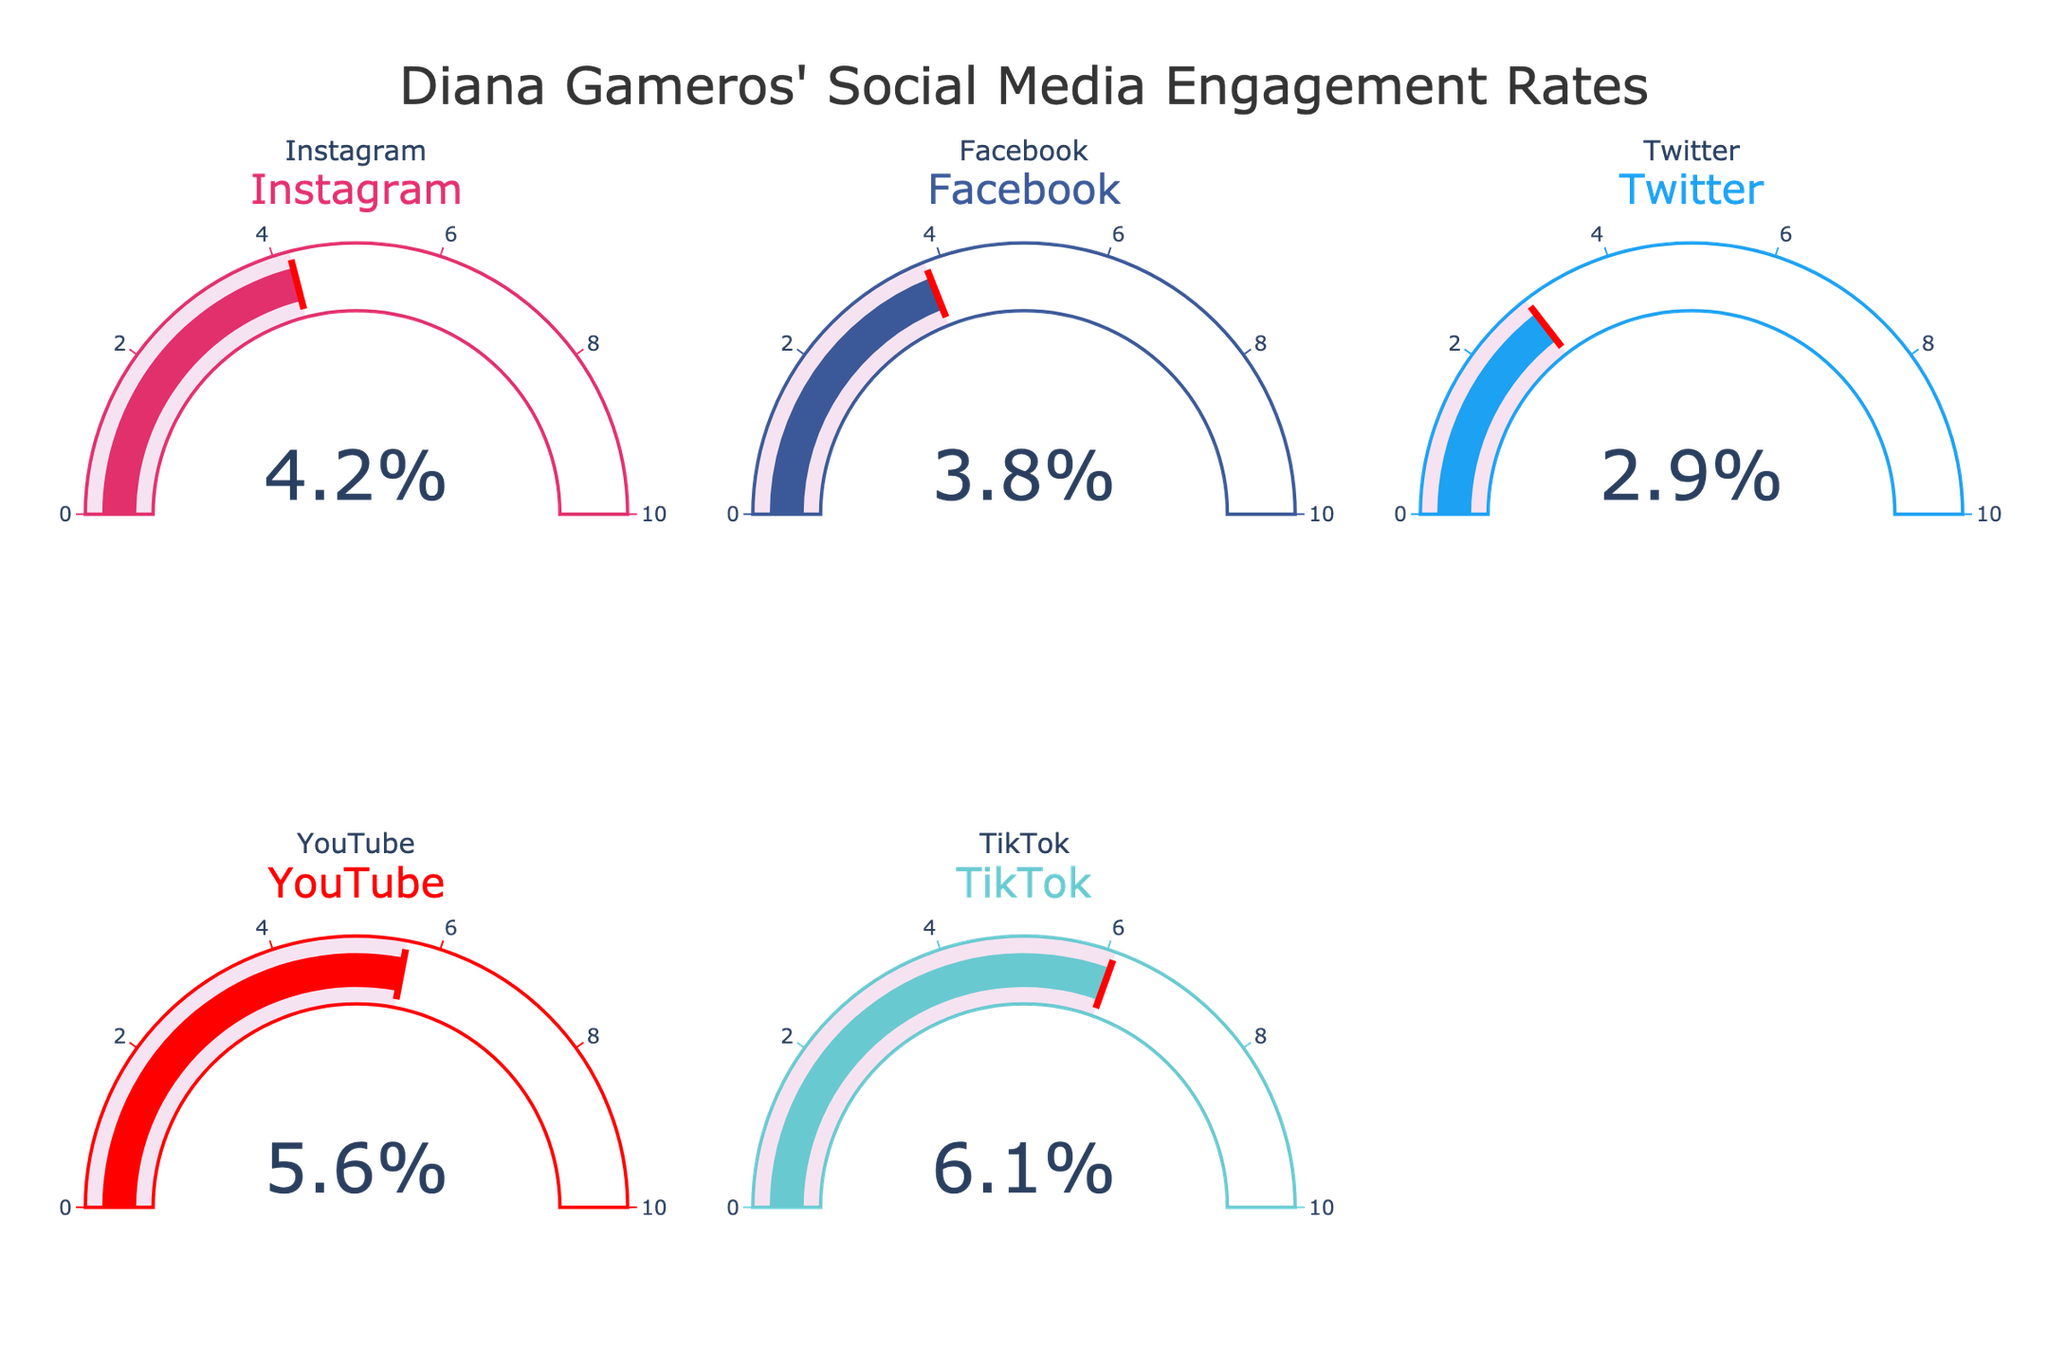What is the highest engagement rate among all platforms? The gauge chart shows individual engagement rates as percentages for each platform. The platform with the highest value is TikTok at 6.1%.
Answer: 6.1% What is the engagement rate for YouTube? The gauge chart individually displays the engagement rate for YouTube, which is 5.6%.
Answer: 5.6% Which platform has the lowest engagement rate? By comparing the individual values displayed on the gauge charts, Twitter has the lowest engagement rate at 2.9%.
Answer: Twitter What is the total engagement rate if we sum all platform engagement rates? Sum the individual engagement rates from the gauge charts: 4.2 (Instagram) + 3.8 (Facebook) + 2.9 (Twitter) + 5.6 (YouTube) + 6.1 (TikTok). This equals 22.6%.
Answer: 22.6% How much higher is the TikTok engagement rate compared to Twitter? Subtract Twitter's engagement rate from TikTok's: 6.1% - 2.9% = 3.2%.
Answer: 3.2% Which social media platform is closest to the average engagement rate of all platforms? First, calculate the average by summing all the rates and dividing by the number of platforms: (4.2 + 3.8 + 2.9 + 5.6 + 6.1) / 5 = 4.52%. Facebook, with an engagement rate of 3.8%, is closest to this average.
Answer: Facebook What is the difference between the highest and the lowest engagement rates? Subtract the lowest rate (Twitter at 2.9%) from the highest rate (TikTok at 6.1%): 6.1% - 2.9% = 3.2%.
Answer: 3.2% If Diana were to double her engagement rate on Twitter, what would it be? Double the current rate: 2.9% * 2 = 5.8%.
Answer: 5.8% Which platforms have engagement rates above the average rate? Calculate the average rate (4.52%), then check each platform: TikTok (6.1%), YouTube (5.6%), and Instagram (4.2%). Only TikTok and YouTube exceed the average rate.
Answer: TikTok, YouTube What is the median engagement rate for these platforms? Arrange the rates in ascending order: 2.9%, 3.8%, 4.2%, 5.6%, 6.1%. The median value is the middle one, which is 4.2%.
Answer: 4.2% 